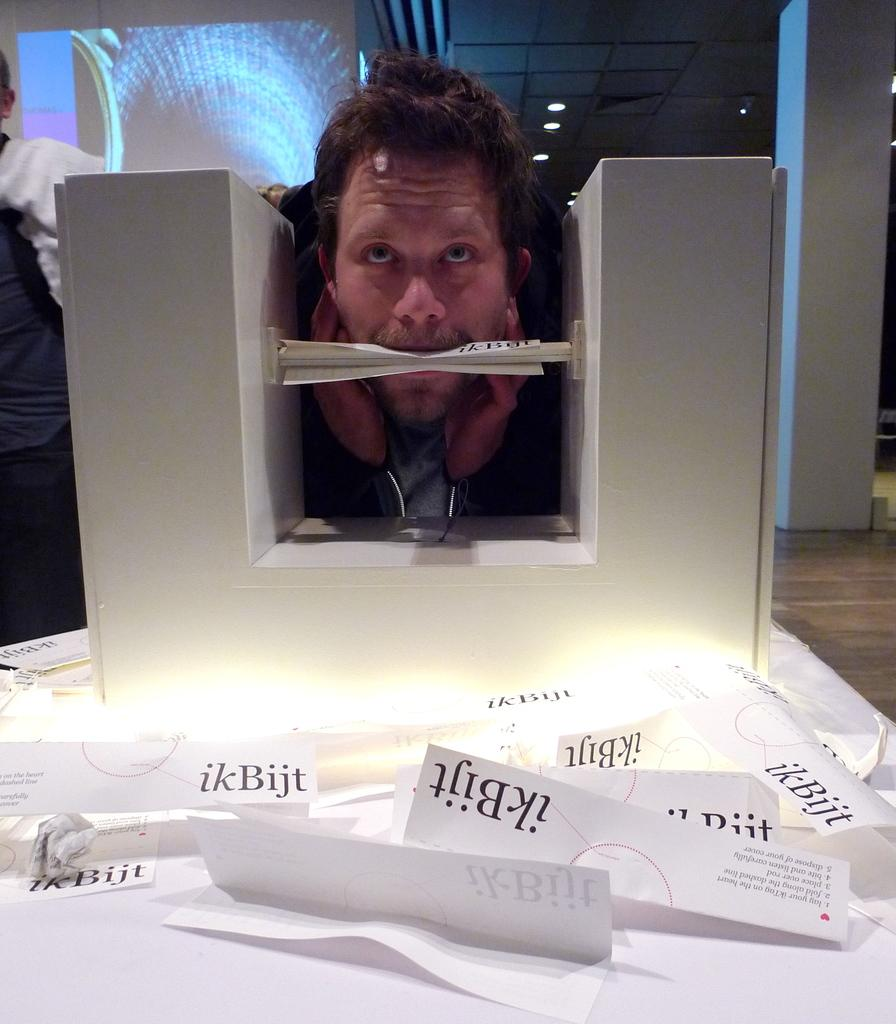<image>
Provide a brief description of the given image. A man is biting a white paper that says ikBijt. 